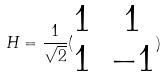Convert formula to latex. <formula><loc_0><loc_0><loc_500><loc_500>H = \frac { 1 } { \sqrt { 2 } } ( \begin{matrix} 1 & 1 \\ 1 & - 1 \end{matrix} )</formula> 